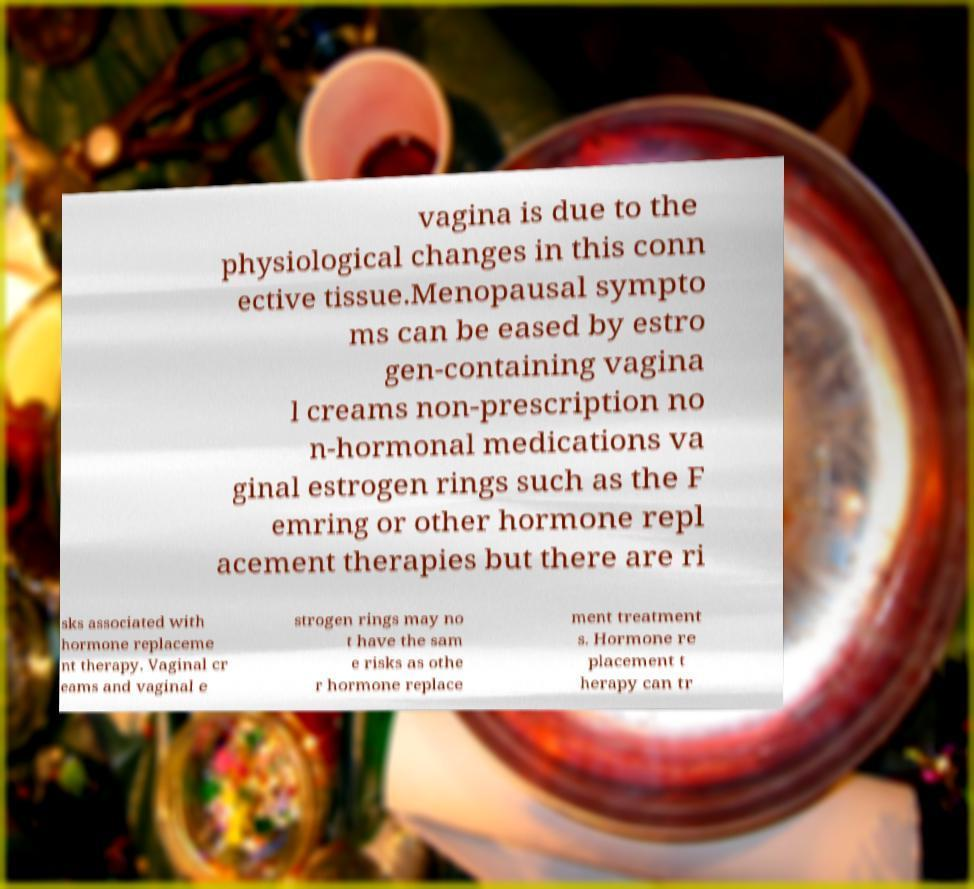There's text embedded in this image that I need extracted. Can you transcribe it verbatim? vagina is due to the physiological changes in this conn ective tissue.Menopausal sympto ms can be eased by estro gen-containing vagina l creams non-prescription no n-hormonal medications va ginal estrogen rings such as the F emring or other hormone repl acement therapies but there are ri sks associated with hormone replaceme nt therapy. Vaginal cr eams and vaginal e strogen rings may no t have the sam e risks as othe r hormone replace ment treatment s. Hormone re placement t herapy can tr 